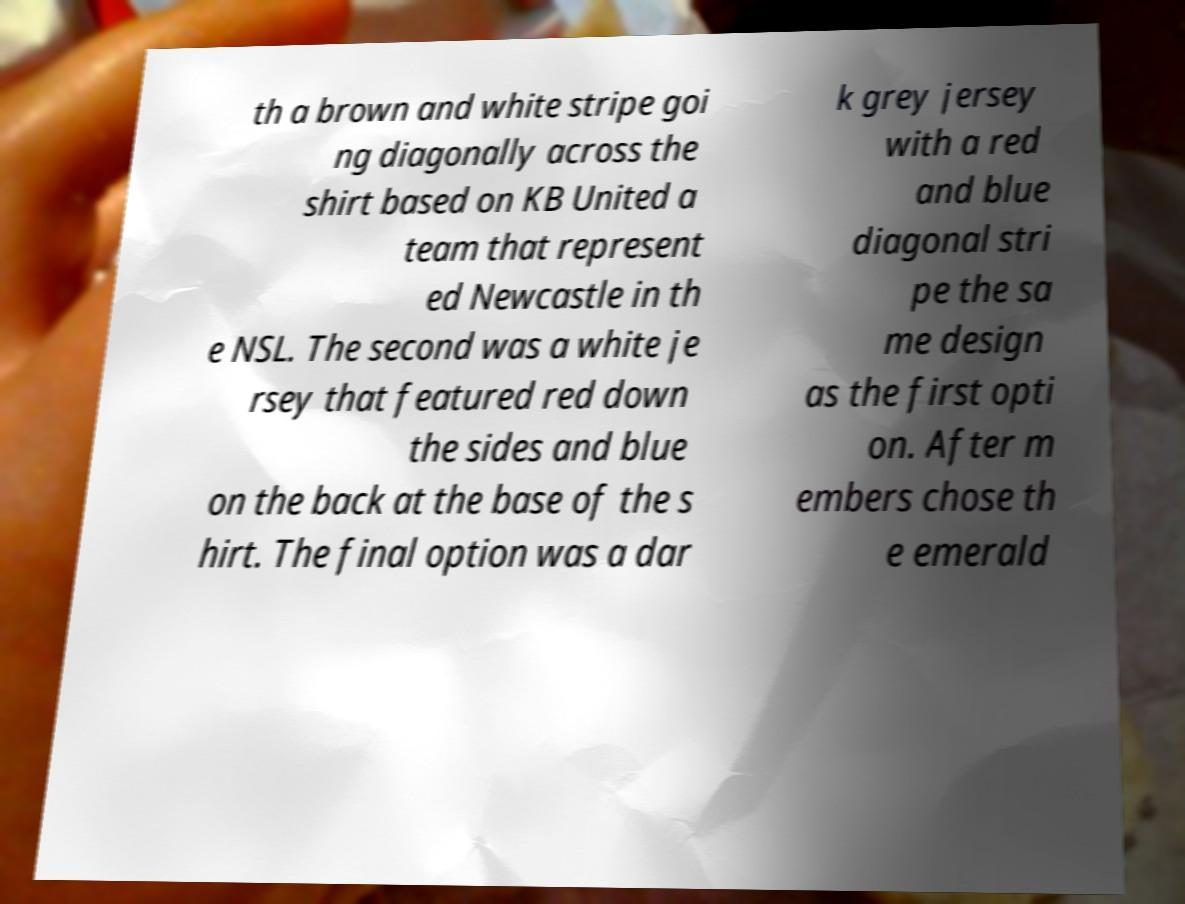Please identify and transcribe the text found in this image. th a brown and white stripe goi ng diagonally across the shirt based on KB United a team that represent ed Newcastle in th e NSL. The second was a white je rsey that featured red down the sides and blue on the back at the base of the s hirt. The final option was a dar k grey jersey with a red and blue diagonal stri pe the sa me design as the first opti on. After m embers chose th e emerald 